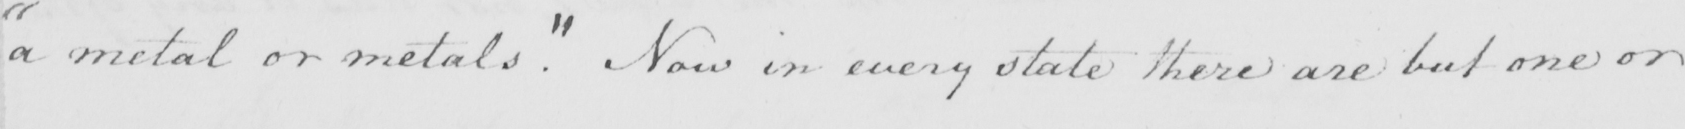Can you read and transcribe this handwriting? " a metal or metals . "  Now in every state there are but one or 